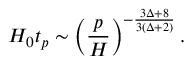Convert formula to latex. <formula><loc_0><loc_0><loc_500><loc_500>H _ { 0 } t _ { p } \sim \left ( \frac { p } { H } \right ) ^ { - \frac { 3 \Delta + 8 } { 3 ( \Delta + 2 ) } } .</formula> 